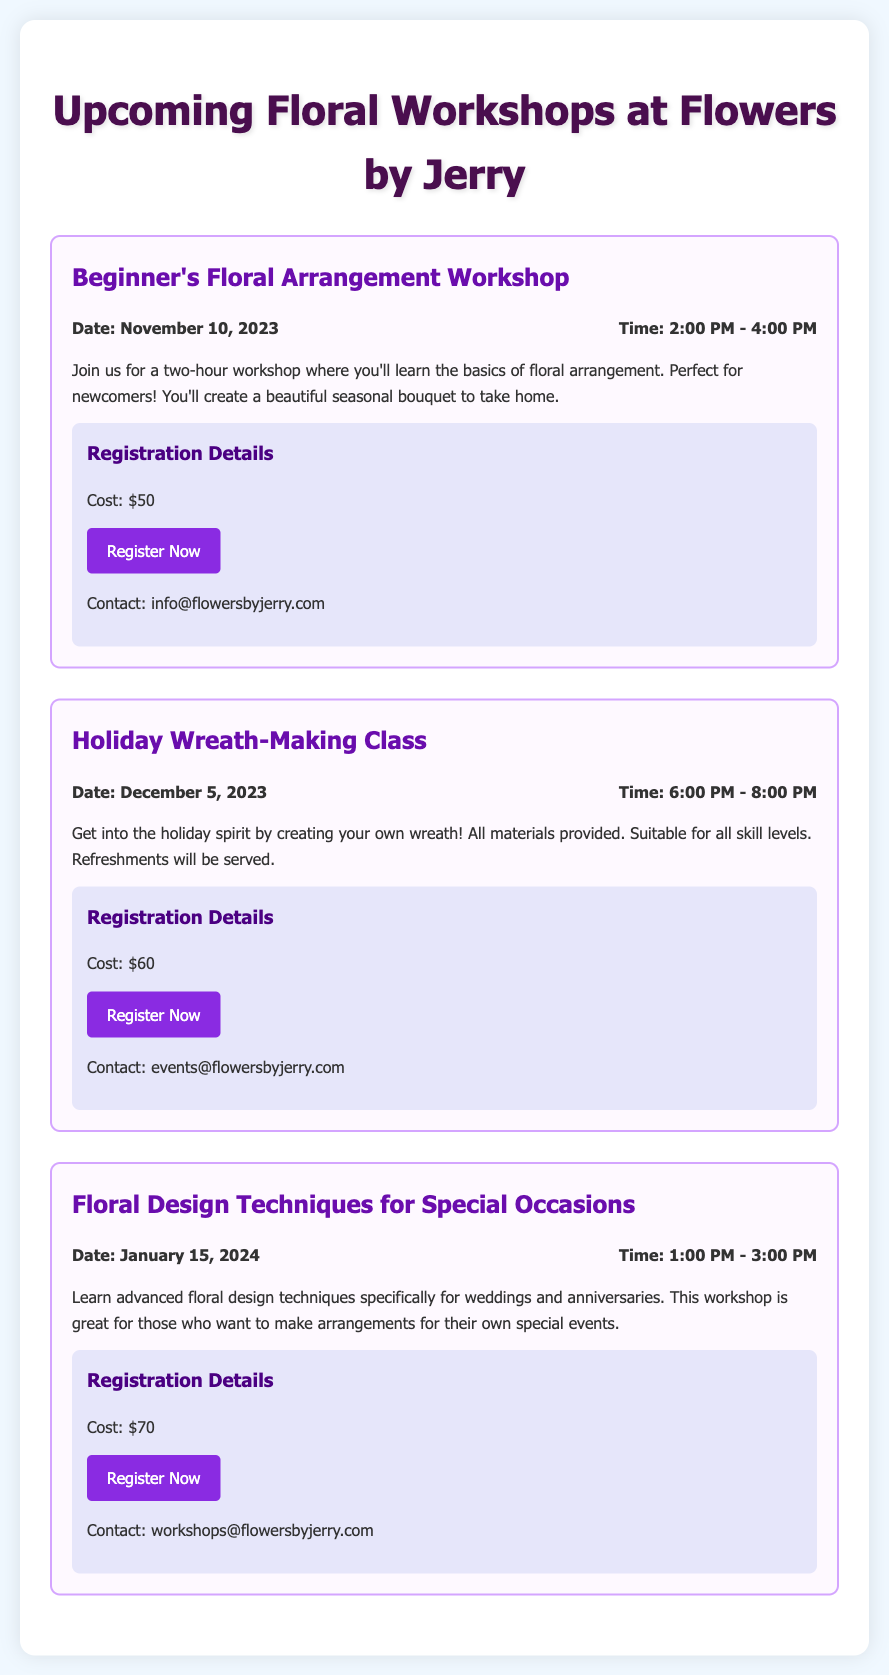What is the date of the Beginner's Floral Arrangement Workshop? The date for the Beginner's Floral Arrangement Workshop is mentioned in the event details.
Answer: November 10, 2023 What is the cost of the Holiday Wreath-Making Class? The cost is specified in the registration details for the Holiday Wreath-Making Class.
Answer: $60 What is the time for the Floral Design Techniques for Special Occasions workshop? The time is provided in the event details section for the Floral Design Techniques for Special Occasions workshop.
Answer: 1:00 PM - 3:00 PM Which event is focused on creating a wreath? The document describes the event that involves creating a wreath in its title and description.
Answer: Holiday Wreath-Making Class How long is the Beginner's Floral Arrangement Workshop? The duration of the workshop is stated in the description of the event.
Answer: Two hours What is the contact email for the Floral Design Techniques workshop? The document provides a specific contact email for inquiries related to the workshop.
Answer: workshops@flowersbyjerry.com What materials are provided for the Holiday Wreath-Making Class? The information about materials is included in the event description of the class.
Answer: All materials provided What is the theme of the workshop on January 15, 2024? The theme is revealed in the title and description, indicating the focus of the workshop.
Answer: Advanced floral design techniques for weddings and anniversaries 